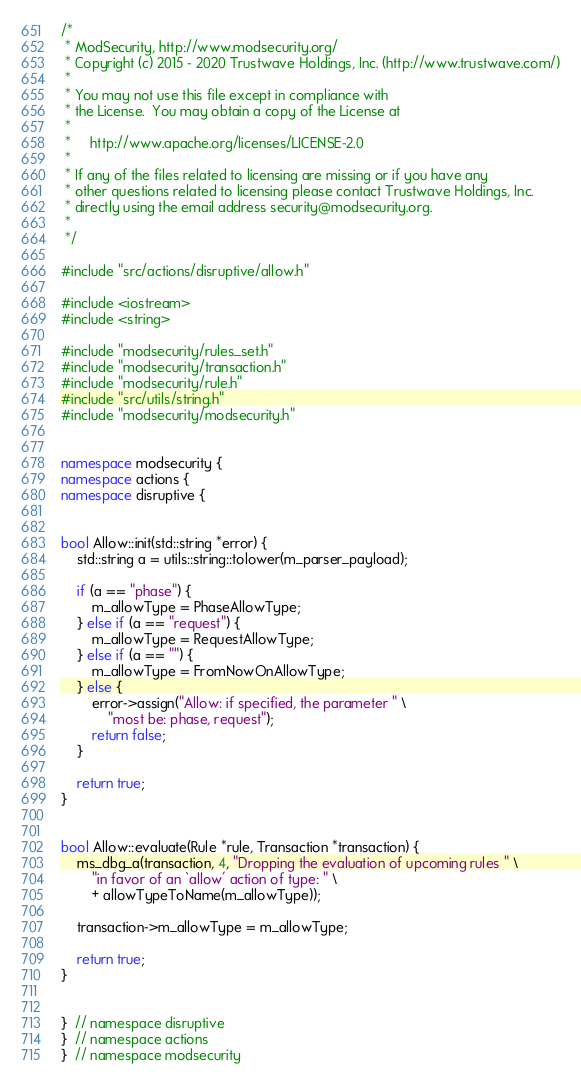<code> <loc_0><loc_0><loc_500><loc_500><_C++_>/*
 * ModSecurity, http://www.modsecurity.org/
 * Copyright (c) 2015 - 2020 Trustwave Holdings, Inc. (http://www.trustwave.com/)
 *
 * You may not use this file except in compliance with
 * the License.  You may obtain a copy of the License at
 *
 *     http://www.apache.org/licenses/LICENSE-2.0
 *
 * If any of the files related to licensing are missing or if you have any
 * other questions related to licensing please contact Trustwave Holdings, Inc.
 * directly using the email address security@modsecurity.org.
 *
 */

#include "src/actions/disruptive/allow.h"

#include <iostream>
#include <string>

#include "modsecurity/rules_set.h"
#include "modsecurity/transaction.h"
#include "modsecurity/rule.h"
#include "src/utils/string.h"
#include "modsecurity/modsecurity.h"


namespace modsecurity {
namespace actions {
namespace disruptive {


bool Allow::init(std::string *error) {
    std::string a = utils::string::tolower(m_parser_payload);

    if (a == "phase") {
        m_allowType = PhaseAllowType;
    } else if (a == "request") {
        m_allowType = RequestAllowType;
    } else if (a == "") {
        m_allowType = FromNowOnAllowType;
    } else {
        error->assign("Allow: if specified, the parameter " \
            "most be: phase, request");
        return false;
    }

    return true;
}


bool Allow::evaluate(Rule *rule, Transaction *transaction) {
    ms_dbg_a(transaction, 4, "Dropping the evaluation of upcoming rules " \
        "in favor of an `allow' action of type: " \
        + allowTypeToName(m_allowType));

    transaction->m_allowType = m_allowType;

    return true;
}


}  // namespace disruptive
}  // namespace actions
}  // namespace modsecurity
</code> 